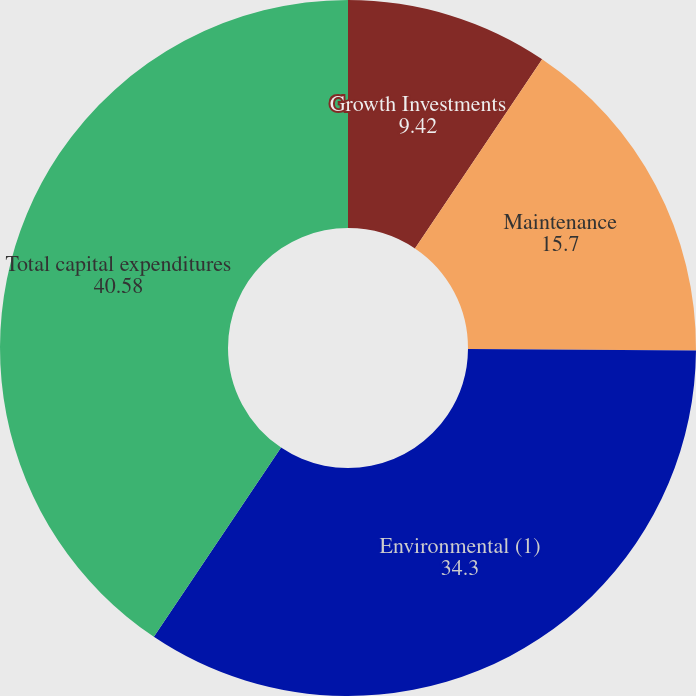Convert chart to OTSL. <chart><loc_0><loc_0><loc_500><loc_500><pie_chart><fcel>Growth Investments<fcel>Maintenance<fcel>Environmental (1)<fcel>Total capital expenditures<nl><fcel>9.42%<fcel>15.7%<fcel>34.3%<fcel>40.58%<nl></chart> 